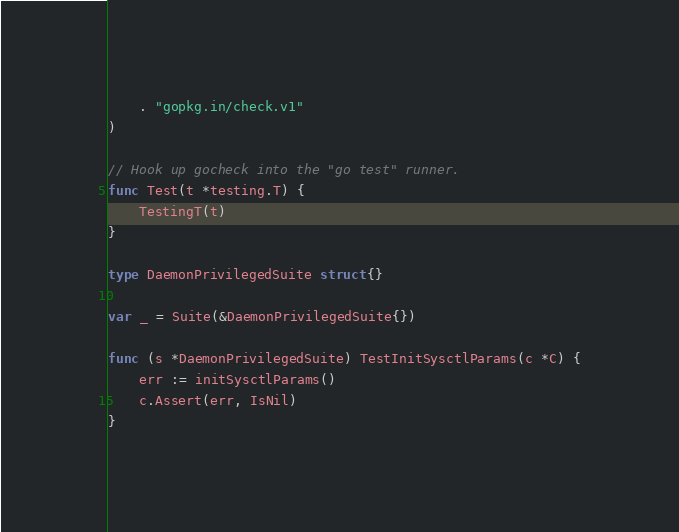<code> <loc_0><loc_0><loc_500><loc_500><_Go_>	. "gopkg.in/check.v1"
)

// Hook up gocheck into the "go test" runner.
func Test(t *testing.T) {
	TestingT(t)
}

type DaemonPrivilegedSuite struct{}

var _ = Suite(&DaemonPrivilegedSuite{})

func (s *DaemonPrivilegedSuite) TestInitSysctlParams(c *C) {
	err := initSysctlParams()
	c.Assert(err, IsNil)
}
</code> 